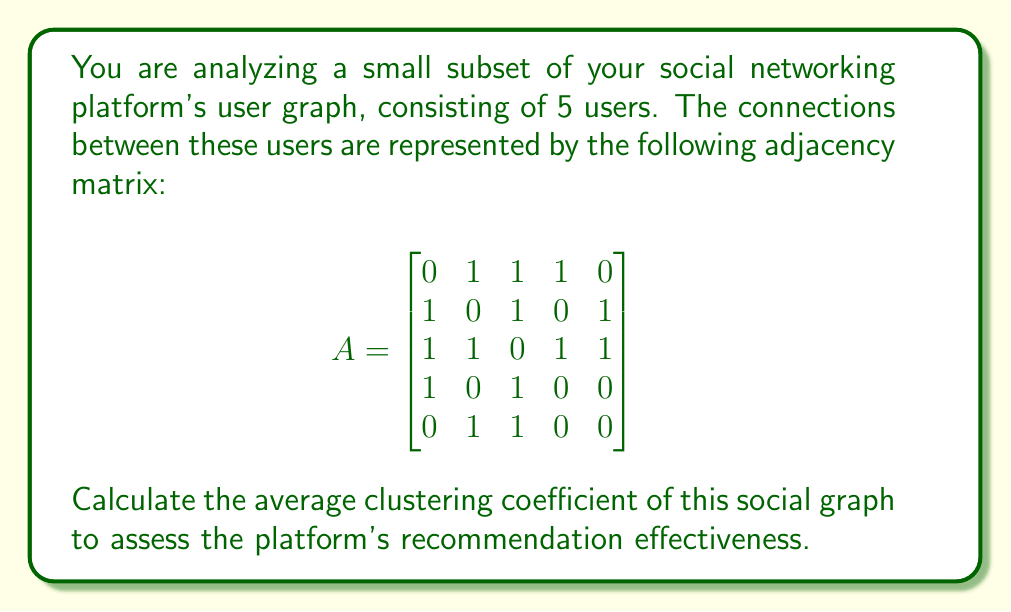Provide a solution to this math problem. To calculate the average clustering coefficient, we need to follow these steps:

1. For each node, determine its degree (number of connections).
2. Calculate the number of triangles each node is part of.
3. Compute the clustering coefficient for each node.
4. Calculate the average of all node clustering coefficients.

Let's go through each step:

1. Degree of each node:
   Node 1: 3, Node 2: 3, Node 3: 4, Node 4: 2, Node 5: 2

2. Number of triangles for each node:
   Node 1: 2 (1-2-3, 1-3-4)
   Node 2: 2 (1-2-3, 2-3-5)
   Node 3: 4 (1-2-3, 1-3-4, 2-3-5, 3-4-1)
   Node 4: 1 (1-3-4)
   Node 5: 1 (2-3-5)

3. Clustering coefficient for each node:
   The formula is: $C_i = \frac{2 \times \text{number of triangles}}{\text{degree} \times (\text{degree} - 1)}$

   Node 1: $C_1 = \frac{2 \times 2}{3 \times 2} = \frac{4}{6} = \frac{2}{3}$
   Node 2: $C_2 = \frac{2 \times 2}{3 \times 2} = \frac{4}{6} = \frac{2}{3}$
   Node 3: $C_3 = \frac{2 \times 4}{4 \times 3} = \frac{8}{12} = \frac{2}{3}$
   Node 4: $C_4 = \frac{2 \times 1}{2 \times 1} = 1$
   Node 5: $C_5 = \frac{2 \times 1}{2 \times 1} = 1$

4. Average clustering coefficient:
   $C_{avg} = \frac{C_1 + C_2 + C_3 + C_4 + C_5}{5} = \frac{\frac{2}{3} + \frac{2}{3} + \frac{2}{3} + 1 + 1}{5} = \frac{4}{5} = 0.8$

Therefore, the average clustering coefficient of this social graph is 0.8.
Answer: 0.8 